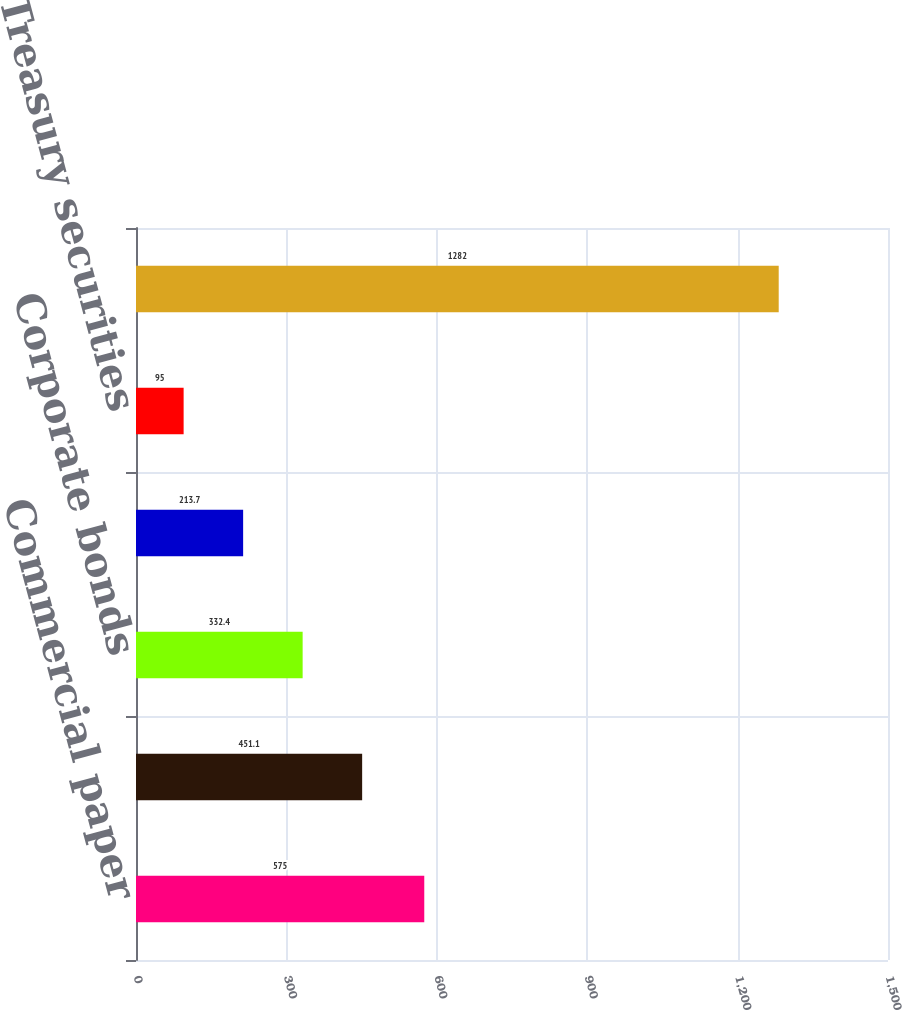<chart> <loc_0><loc_0><loc_500><loc_500><bar_chart><fcel>Commercial paper<fcel>US agency securities<fcel>Corporate bonds<fcel>Asset-backed securities<fcel>US Treasury securities<fcel>Total short-term investments<nl><fcel>575<fcel>451.1<fcel>332.4<fcel>213.7<fcel>95<fcel>1282<nl></chart> 